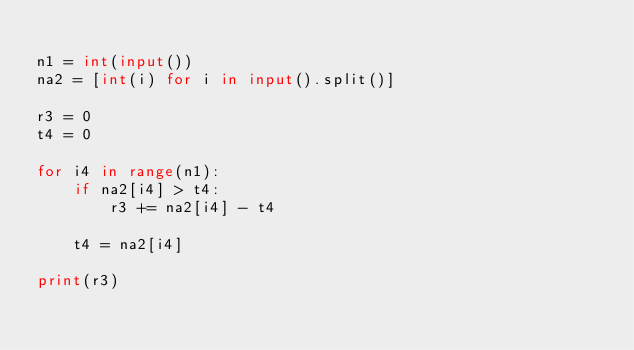Convert code to text. <code><loc_0><loc_0><loc_500><loc_500><_Python_>
n1 = int(input())
na2 = [int(i) for i in input().split()]

r3 = 0
t4 = 0

for i4 in range(n1):
    if na2[i4] > t4:
        r3 += na2[i4] - t4
    
    t4 = na2[i4]

print(r3)</code> 